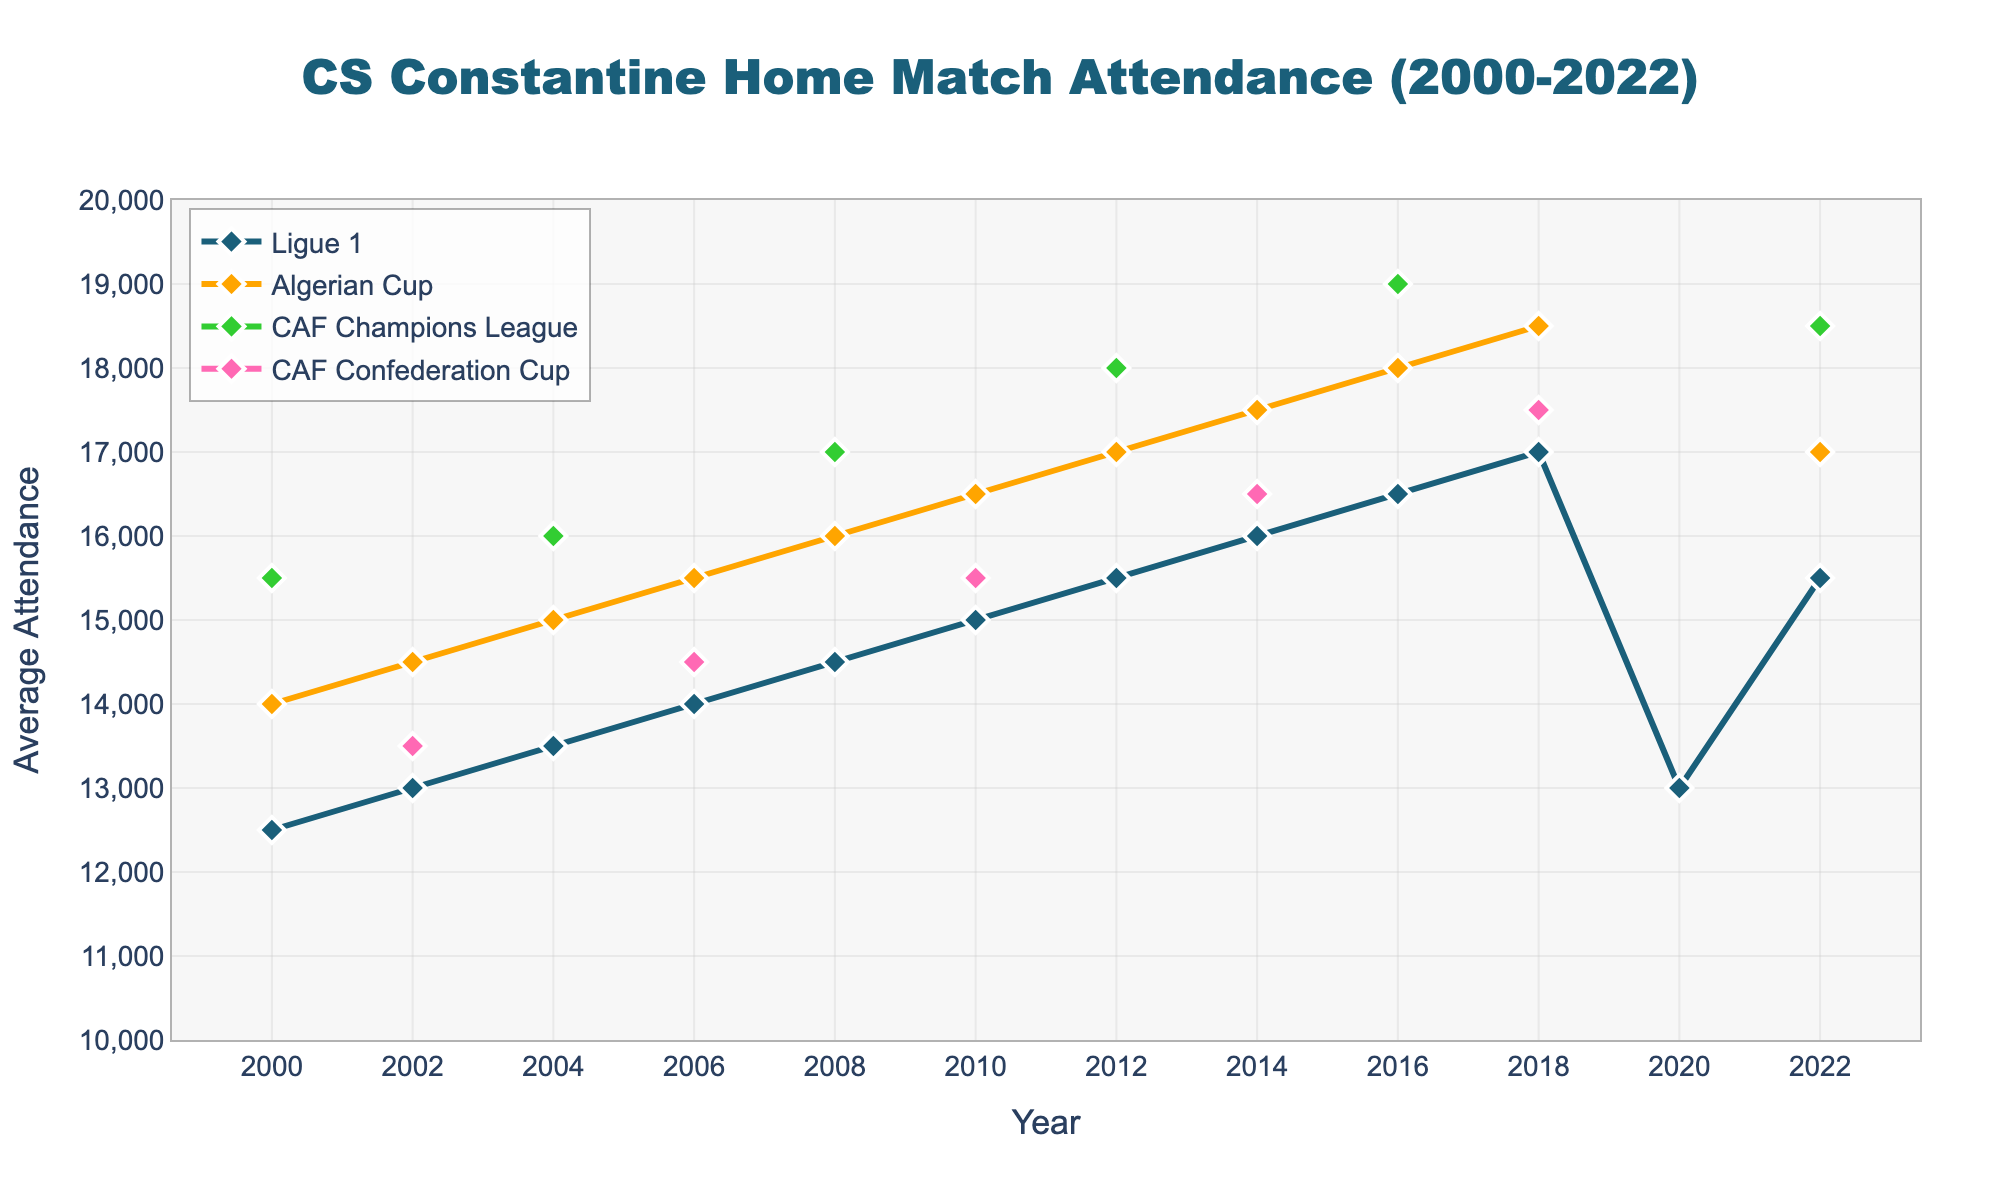Which competition had the highest average attendance in 2004? Check the attendance values for all competitions in 2004. Highest attendance is 16,000 for CAF Champions League.
Answer: CAF Champions League In which year did Ligue 1 have the lowest average attendance? Look at the Ligue 1 attendance values over the years. The lowest is 13,000 in 2020.
Answer: 2020 How many years have data available for the CAF Confederation Cup? Count the number of entries for the CAF Confederation Cup that are not 'N/A'. The years are 2002, 2006, and 2018.
Answer: 3 What is the difference between the highest and lowest average attendance in the Algerian Cup competitions? Find the highest (18,500 in 2018) and lowest (14,000 in 2000) attendance values in the Algerian Cup. The difference is 18,500 - 14,000 = 4,500.
Answer: 4,500 What was the average attendance for CS Constantine across all competitions in 2016? Sum up the attendance values for all available competitions in 2016 (Ligue 1 = 16,500, Algerian Cup = 18,000, CAF Champions League = 19,000). Their average is (16,500 + 18,000 + 19,000)/3 = 17,833.33.
Answer: 17,833.33 Which years had average attendance values for the CAF Champions League? Look at the years in the data and identify where the CAF Champions League values are provided. The years are 2000, 2004, 2008, 2012, 2016, and 2022.
Answer: 2000, 2004, 2008, 2012, 2016, 2022 In which competition does the trend show a consistent increase in average attendance from 2000 to 2018? Check the attendance values over the years for each competition. Only Ligue 1 shows a consistent increase (12,500 in 2000 to 17,000 in 2018).
Answer: Ligue 1 What was the combined average attendance for Ligue 1 and CAF Confederation Cup in 2002? Add the average attendances of Ligue 1 and CAF Confederation Cup in 2002 (13,000 + 13,500) = 26,500.
Answer: 26,500 Which competition had the closest attendance to 15,000 in 2010? Compare the attendance values in 2010 to 15,000. Ligue 1 had exactly 15,000 attendance in 2010.
Answer: Ligue 1 What was the average attendance in the Algerian Cup over all years? Sum all provided Algerian Cup attendances and divide by the number of years with data (14,000 + 14,500 + 15,000 + 15,500 + 16,000 + 16,500 + 17,000 + 17,500 + 18,000 + 18,500 + 17,000) / 11 = 16,136.36.
Answer: 16,136.36 